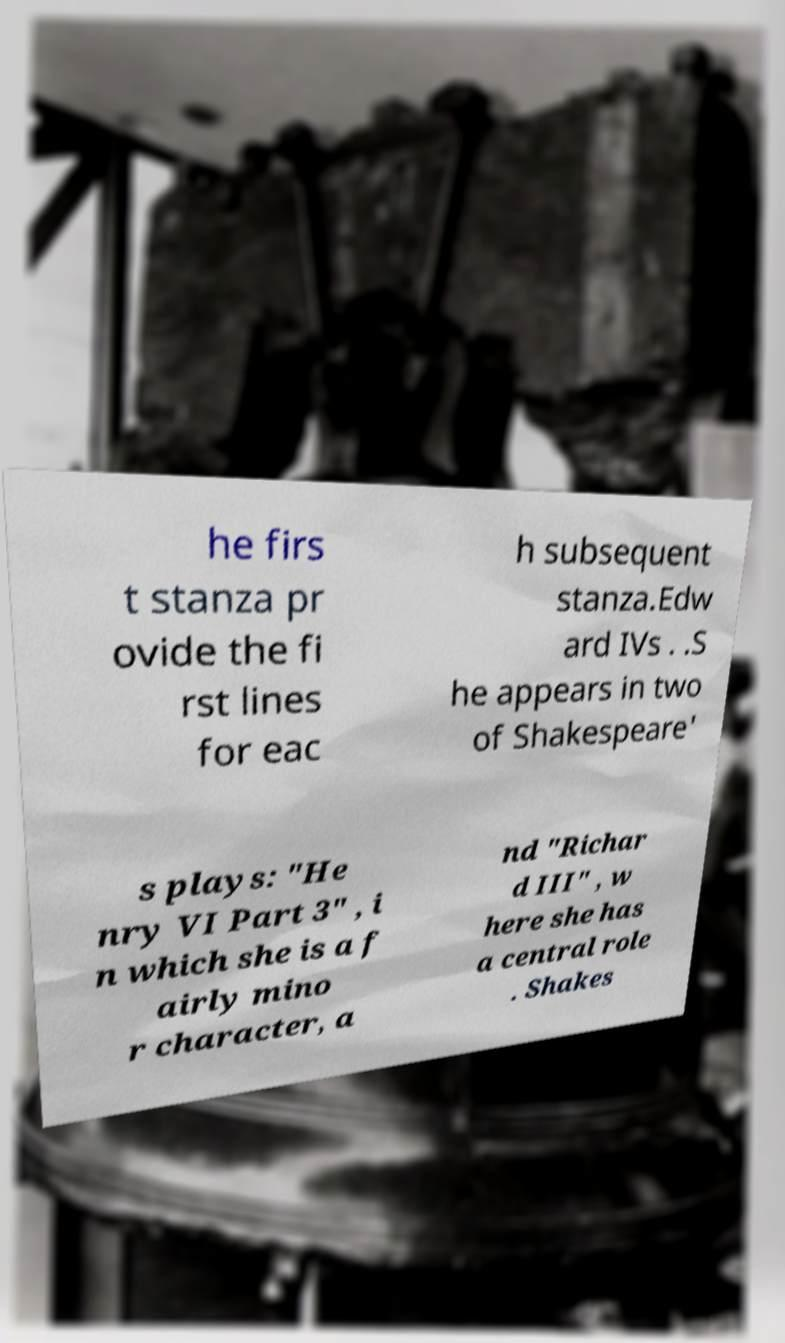Can you read and provide the text displayed in the image?This photo seems to have some interesting text. Can you extract and type it out for me? he firs t stanza pr ovide the fi rst lines for eac h subsequent stanza.Edw ard IVs . .S he appears in two of Shakespeare' s plays: "He nry VI Part 3" , i n which she is a f airly mino r character, a nd "Richar d III" , w here she has a central role . Shakes 